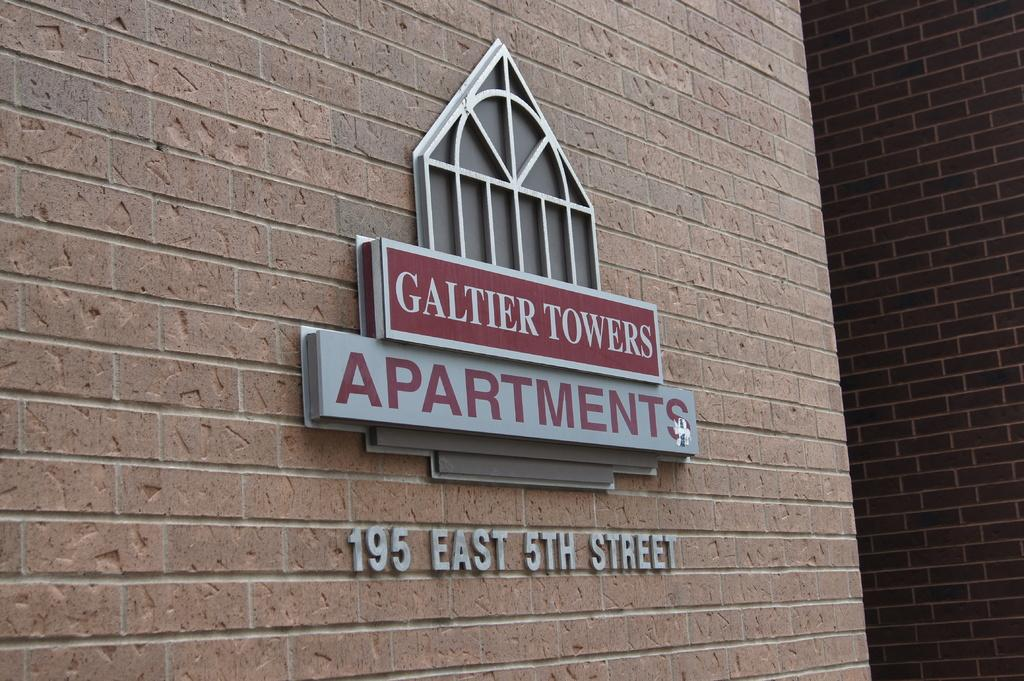What is present in the image? There is a wall in the image. What is featured on the wall? There is text written on the wall. What is the existence of the statement on the wall referring to in the image? There is no specific statement mentioned in the facts provided, so it is not possible to determine what the existence of the statement might be referring to. 